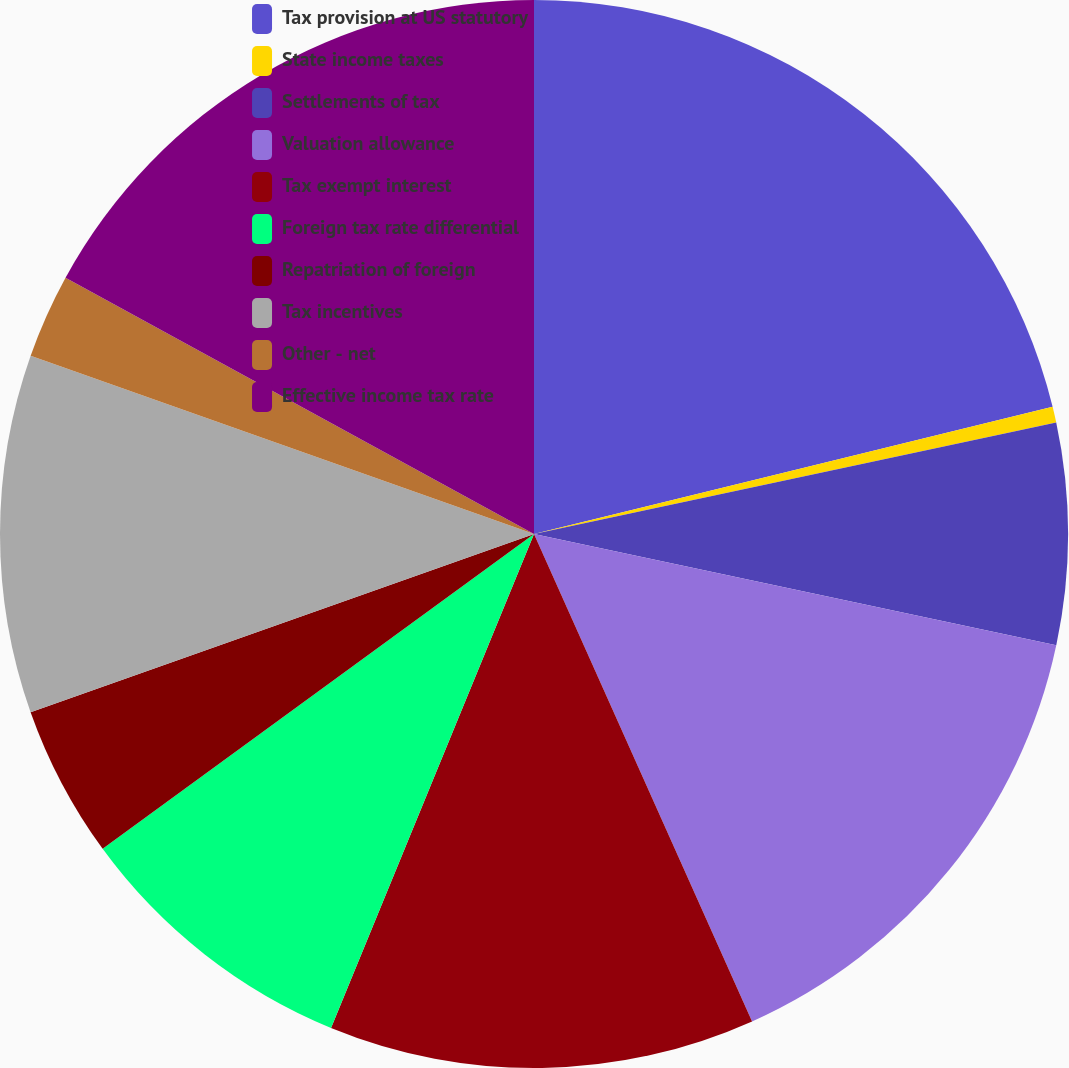Convert chart. <chart><loc_0><loc_0><loc_500><loc_500><pie_chart><fcel>Tax provision at US statutory<fcel>State income taxes<fcel>Settlements of tax<fcel>Valuation allowance<fcel>Tax exempt interest<fcel>Foreign tax rate differential<fcel>Repatriation of foreign<fcel>Tax incentives<fcel>Other - net<fcel>Effective income tax rate<nl><fcel>21.17%<fcel>0.48%<fcel>6.69%<fcel>14.96%<fcel>12.9%<fcel>8.76%<fcel>4.62%<fcel>10.83%<fcel>2.55%<fcel>17.03%<nl></chart> 